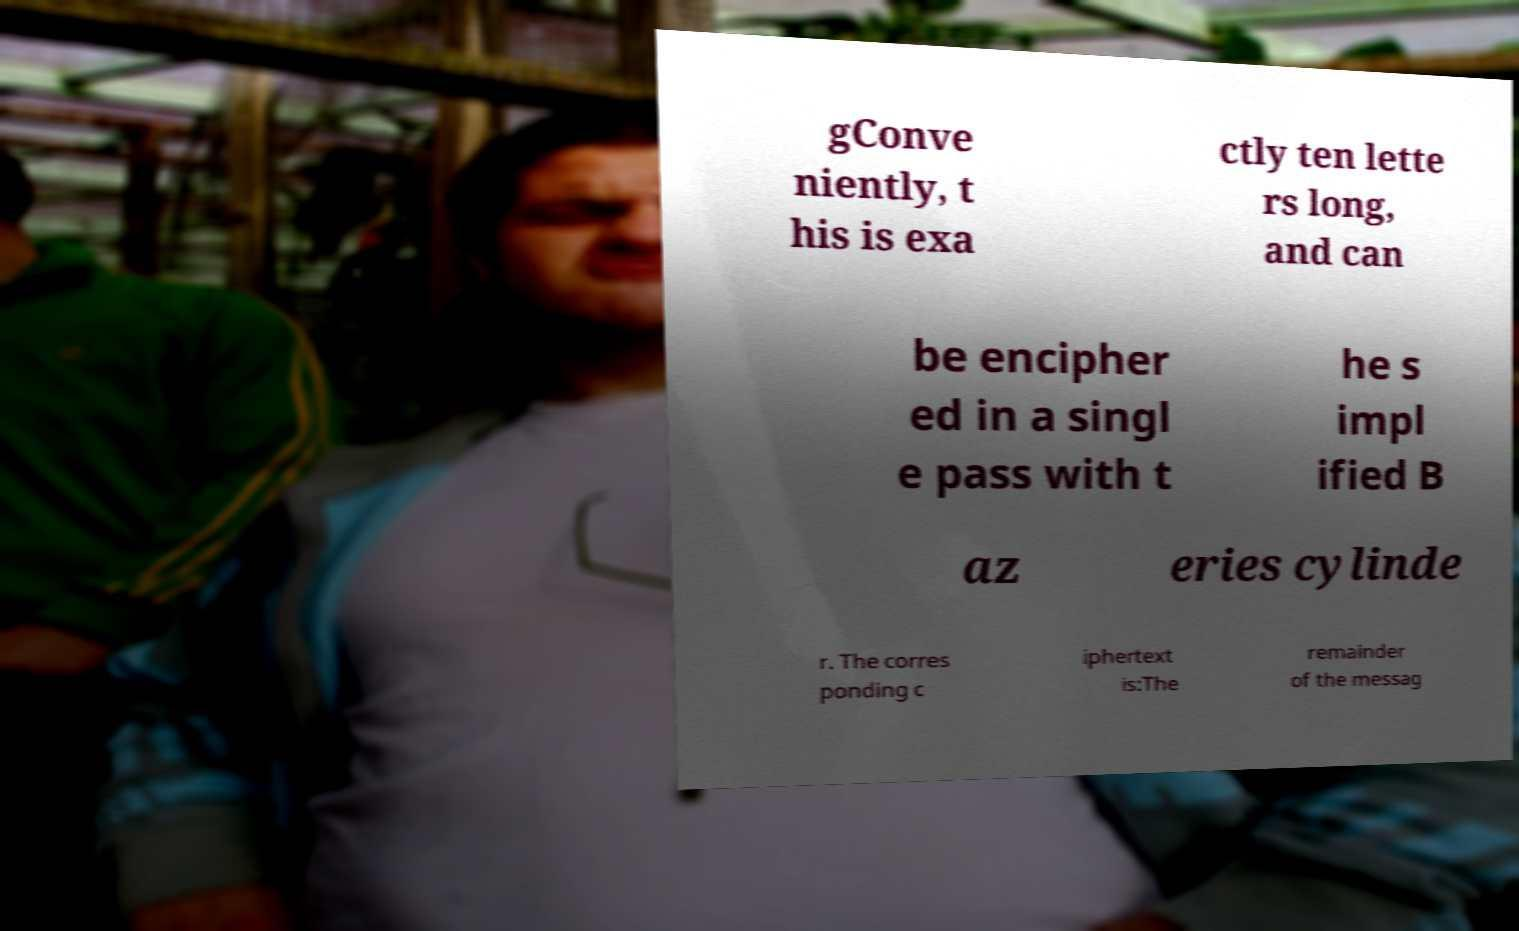Can you read and provide the text displayed in the image?This photo seems to have some interesting text. Can you extract and type it out for me? gConve niently, t his is exa ctly ten lette rs long, and can be encipher ed in a singl e pass with t he s impl ified B az eries cylinde r. The corres ponding c iphertext is:The remainder of the messag 